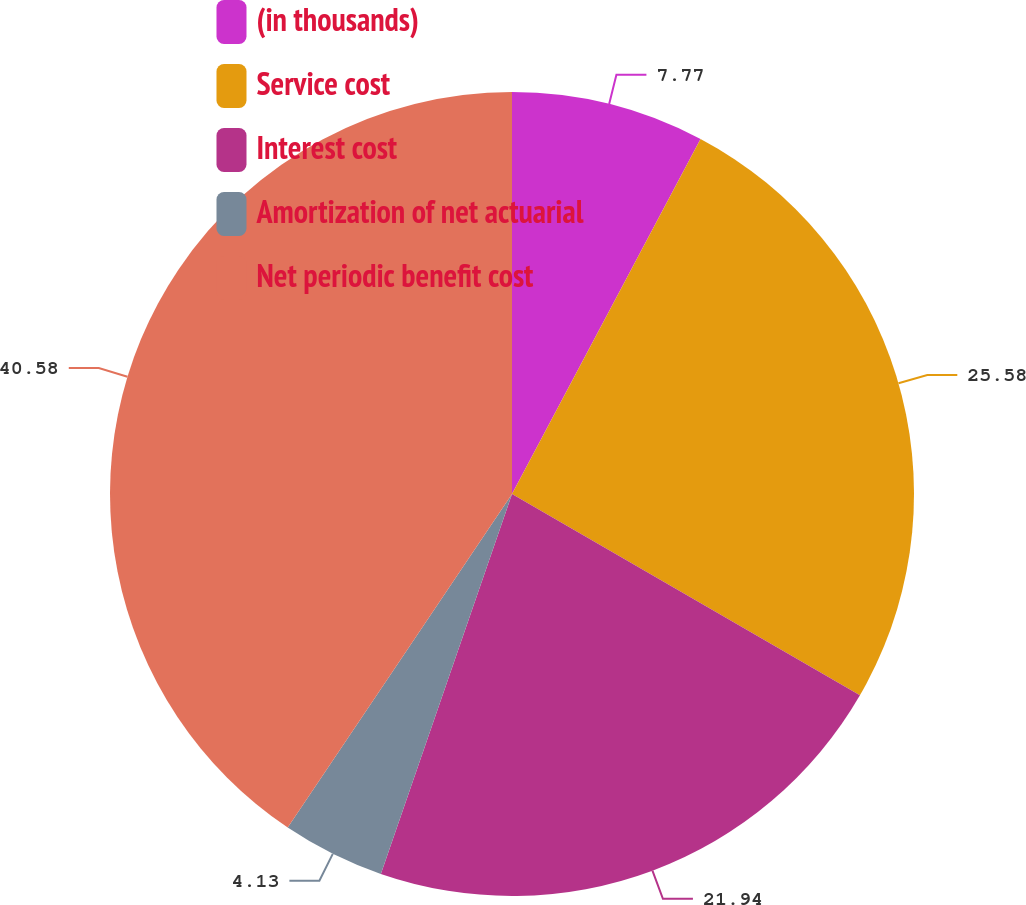<chart> <loc_0><loc_0><loc_500><loc_500><pie_chart><fcel>(in thousands)<fcel>Service cost<fcel>Interest cost<fcel>Amortization of net actuarial<fcel>Net periodic benefit cost<nl><fcel>7.77%<fcel>25.58%<fcel>21.94%<fcel>4.13%<fcel>40.58%<nl></chart> 